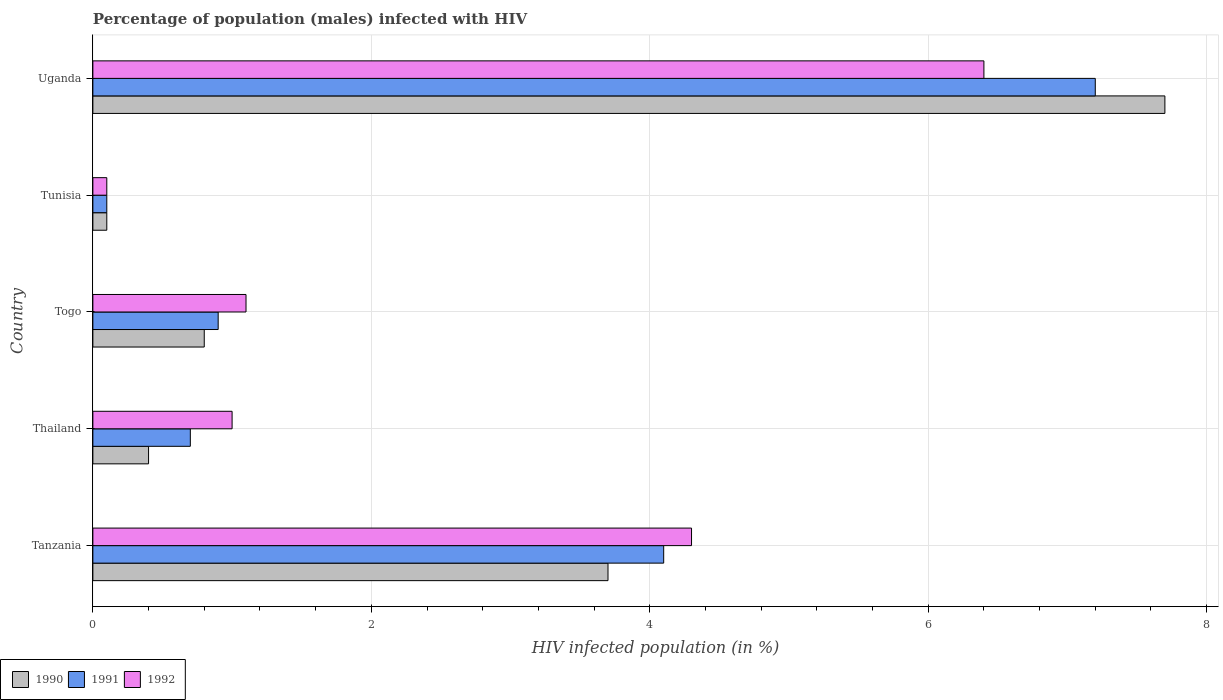Are the number of bars per tick equal to the number of legend labels?
Offer a terse response. Yes. How many bars are there on the 1st tick from the top?
Keep it short and to the point. 3. What is the label of the 1st group of bars from the top?
Keep it short and to the point. Uganda. In how many cases, is the number of bars for a given country not equal to the number of legend labels?
Ensure brevity in your answer.  0. What is the percentage of HIV infected male population in 1991 in Tanzania?
Your answer should be very brief. 4.1. Across all countries, what is the maximum percentage of HIV infected male population in 1990?
Your answer should be compact. 7.7. In which country was the percentage of HIV infected male population in 1991 maximum?
Give a very brief answer. Uganda. In which country was the percentage of HIV infected male population in 1991 minimum?
Make the answer very short. Tunisia. What is the difference between the percentage of HIV infected male population in 1990 in Tanzania and that in Togo?
Provide a succinct answer. 2.9. What is the average percentage of HIV infected male population in 1992 per country?
Your answer should be compact. 2.58. What is the difference between the percentage of HIV infected male population in 1992 and percentage of HIV infected male population in 1991 in Tanzania?
Ensure brevity in your answer.  0.2. What is the difference between the highest and the lowest percentage of HIV infected male population in 1991?
Offer a terse response. 7.1. In how many countries, is the percentage of HIV infected male population in 1990 greater than the average percentage of HIV infected male population in 1990 taken over all countries?
Provide a short and direct response. 2. Is the sum of the percentage of HIV infected male population in 1990 in Togo and Uganda greater than the maximum percentage of HIV infected male population in 1991 across all countries?
Give a very brief answer. Yes. What does the 3rd bar from the bottom in Togo represents?
Your answer should be very brief. 1992. Is it the case that in every country, the sum of the percentage of HIV infected male population in 1991 and percentage of HIV infected male population in 1992 is greater than the percentage of HIV infected male population in 1990?
Keep it short and to the point. Yes. How many bars are there?
Give a very brief answer. 15. Are all the bars in the graph horizontal?
Offer a terse response. Yes. How many countries are there in the graph?
Ensure brevity in your answer.  5. What is the difference between two consecutive major ticks on the X-axis?
Your response must be concise. 2. Does the graph contain any zero values?
Keep it short and to the point. No. Where does the legend appear in the graph?
Keep it short and to the point. Bottom left. How many legend labels are there?
Give a very brief answer. 3. How are the legend labels stacked?
Provide a succinct answer. Horizontal. What is the title of the graph?
Offer a very short reply. Percentage of population (males) infected with HIV. Does "1989" appear as one of the legend labels in the graph?
Offer a terse response. No. What is the label or title of the X-axis?
Ensure brevity in your answer.  HIV infected population (in %). What is the label or title of the Y-axis?
Your answer should be very brief. Country. What is the HIV infected population (in %) in 1991 in Tanzania?
Your answer should be compact. 4.1. What is the HIV infected population (in %) of 1991 in Thailand?
Provide a short and direct response. 0.7. What is the HIV infected population (in %) in 1992 in Thailand?
Give a very brief answer. 1. What is the HIV infected population (in %) in 1991 in Tunisia?
Offer a terse response. 0.1. What is the HIV infected population (in %) of 1990 in Uganda?
Keep it short and to the point. 7.7. What is the HIV infected population (in %) in 1991 in Uganda?
Offer a terse response. 7.2. What is the HIV infected population (in %) in 1992 in Uganda?
Offer a very short reply. 6.4. Across all countries, what is the maximum HIV infected population (in %) of 1990?
Your answer should be compact. 7.7. Across all countries, what is the maximum HIV infected population (in %) in 1992?
Offer a terse response. 6.4. Across all countries, what is the minimum HIV infected population (in %) of 1991?
Your answer should be compact. 0.1. Across all countries, what is the minimum HIV infected population (in %) of 1992?
Keep it short and to the point. 0.1. What is the total HIV infected population (in %) of 1990 in the graph?
Offer a terse response. 12.7. What is the difference between the HIV infected population (in %) in 1990 in Tanzania and that in Thailand?
Provide a short and direct response. 3.3. What is the difference between the HIV infected population (in %) in 1991 in Tanzania and that in Togo?
Offer a terse response. 3.2. What is the difference between the HIV infected population (in %) in 1992 in Tanzania and that in Togo?
Provide a short and direct response. 3.2. What is the difference between the HIV infected population (in %) of 1990 in Tanzania and that in Tunisia?
Make the answer very short. 3.6. What is the difference between the HIV infected population (in %) in 1992 in Tanzania and that in Tunisia?
Offer a very short reply. 4.2. What is the difference between the HIV infected population (in %) of 1991 in Tanzania and that in Uganda?
Your answer should be compact. -3.1. What is the difference between the HIV infected population (in %) of 1992 in Tanzania and that in Uganda?
Your answer should be compact. -2.1. What is the difference between the HIV infected population (in %) of 1990 in Thailand and that in Tunisia?
Offer a very short reply. 0.3. What is the difference between the HIV infected population (in %) in 1992 in Thailand and that in Tunisia?
Keep it short and to the point. 0.9. What is the difference between the HIV infected population (in %) in 1990 in Thailand and that in Uganda?
Provide a short and direct response. -7.3. What is the difference between the HIV infected population (in %) in 1991 in Thailand and that in Uganda?
Provide a short and direct response. -6.5. What is the difference between the HIV infected population (in %) in 1992 in Thailand and that in Uganda?
Your answer should be very brief. -5.4. What is the difference between the HIV infected population (in %) in 1992 in Togo and that in Tunisia?
Provide a short and direct response. 1. What is the difference between the HIV infected population (in %) in 1992 in Togo and that in Uganda?
Offer a very short reply. -5.3. What is the difference between the HIV infected population (in %) of 1990 in Tunisia and that in Uganda?
Offer a terse response. -7.6. What is the difference between the HIV infected population (in %) in 1992 in Tunisia and that in Uganda?
Your response must be concise. -6.3. What is the difference between the HIV infected population (in %) of 1990 in Tanzania and the HIV infected population (in %) of 1992 in Thailand?
Offer a very short reply. 2.7. What is the difference between the HIV infected population (in %) of 1990 in Tanzania and the HIV infected population (in %) of 1992 in Togo?
Make the answer very short. 2.6. What is the difference between the HIV infected population (in %) in 1991 in Tanzania and the HIV infected population (in %) in 1992 in Togo?
Give a very brief answer. 3. What is the difference between the HIV infected population (in %) in 1990 in Tanzania and the HIV infected population (in %) in 1992 in Uganda?
Offer a terse response. -2.7. What is the difference between the HIV infected population (in %) of 1990 in Thailand and the HIV infected population (in %) of 1992 in Uganda?
Your answer should be very brief. -6. What is the difference between the HIV infected population (in %) in 1991 in Thailand and the HIV infected population (in %) in 1992 in Uganda?
Offer a very short reply. -5.7. What is the difference between the HIV infected population (in %) in 1990 in Togo and the HIV infected population (in %) in 1991 in Tunisia?
Your response must be concise. 0.7. What is the difference between the HIV infected population (in %) of 1990 in Togo and the HIV infected population (in %) of 1992 in Tunisia?
Offer a terse response. 0.7. What is the difference between the HIV infected population (in %) of 1990 in Togo and the HIV infected population (in %) of 1991 in Uganda?
Give a very brief answer. -6.4. What is the difference between the HIV infected population (in %) of 1991 in Togo and the HIV infected population (in %) of 1992 in Uganda?
Offer a very short reply. -5.5. What is the difference between the HIV infected population (in %) in 1990 in Tunisia and the HIV infected population (in %) in 1992 in Uganda?
Offer a terse response. -6.3. What is the difference between the HIV infected population (in %) of 1991 in Tunisia and the HIV infected population (in %) of 1992 in Uganda?
Offer a terse response. -6.3. What is the average HIV infected population (in %) of 1990 per country?
Offer a very short reply. 2.54. What is the average HIV infected population (in %) in 1991 per country?
Your answer should be very brief. 2.6. What is the average HIV infected population (in %) of 1992 per country?
Ensure brevity in your answer.  2.58. What is the difference between the HIV infected population (in %) of 1990 and HIV infected population (in %) of 1991 in Tanzania?
Provide a short and direct response. -0.4. What is the difference between the HIV infected population (in %) of 1990 and HIV infected population (in %) of 1992 in Tanzania?
Give a very brief answer. -0.6. What is the difference between the HIV infected population (in %) of 1990 and HIV infected population (in %) of 1992 in Thailand?
Your answer should be compact. -0.6. What is the difference between the HIV infected population (in %) in 1991 and HIV infected population (in %) in 1992 in Thailand?
Make the answer very short. -0.3. What is the difference between the HIV infected population (in %) of 1990 and HIV infected population (in %) of 1991 in Togo?
Your answer should be very brief. -0.1. What is the difference between the HIV infected population (in %) of 1990 and HIV infected population (in %) of 1992 in Togo?
Make the answer very short. -0.3. What is the difference between the HIV infected population (in %) of 1990 and HIV infected population (in %) of 1991 in Tunisia?
Your response must be concise. 0. What is the difference between the HIV infected population (in %) of 1990 and HIV infected population (in %) of 1991 in Uganda?
Keep it short and to the point. 0.5. What is the difference between the HIV infected population (in %) of 1991 and HIV infected population (in %) of 1992 in Uganda?
Provide a short and direct response. 0.8. What is the ratio of the HIV infected population (in %) in 1990 in Tanzania to that in Thailand?
Make the answer very short. 9.25. What is the ratio of the HIV infected population (in %) in 1991 in Tanzania to that in Thailand?
Your answer should be compact. 5.86. What is the ratio of the HIV infected population (in %) in 1992 in Tanzania to that in Thailand?
Your response must be concise. 4.3. What is the ratio of the HIV infected population (in %) in 1990 in Tanzania to that in Togo?
Provide a succinct answer. 4.62. What is the ratio of the HIV infected population (in %) in 1991 in Tanzania to that in Togo?
Offer a very short reply. 4.56. What is the ratio of the HIV infected population (in %) in 1992 in Tanzania to that in Togo?
Provide a succinct answer. 3.91. What is the ratio of the HIV infected population (in %) in 1991 in Tanzania to that in Tunisia?
Your response must be concise. 41. What is the ratio of the HIV infected population (in %) in 1992 in Tanzania to that in Tunisia?
Offer a very short reply. 43. What is the ratio of the HIV infected population (in %) in 1990 in Tanzania to that in Uganda?
Offer a very short reply. 0.48. What is the ratio of the HIV infected population (in %) in 1991 in Tanzania to that in Uganda?
Your response must be concise. 0.57. What is the ratio of the HIV infected population (in %) in 1992 in Tanzania to that in Uganda?
Provide a succinct answer. 0.67. What is the ratio of the HIV infected population (in %) of 1991 in Thailand to that in Tunisia?
Your answer should be compact. 7. What is the ratio of the HIV infected population (in %) of 1990 in Thailand to that in Uganda?
Keep it short and to the point. 0.05. What is the ratio of the HIV infected population (in %) in 1991 in Thailand to that in Uganda?
Your answer should be very brief. 0.1. What is the ratio of the HIV infected population (in %) in 1992 in Thailand to that in Uganda?
Your answer should be very brief. 0.16. What is the ratio of the HIV infected population (in %) of 1992 in Togo to that in Tunisia?
Your answer should be very brief. 11. What is the ratio of the HIV infected population (in %) in 1990 in Togo to that in Uganda?
Your answer should be compact. 0.1. What is the ratio of the HIV infected population (in %) of 1991 in Togo to that in Uganda?
Keep it short and to the point. 0.12. What is the ratio of the HIV infected population (in %) in 1992 in Togo to that in Uganda?
Make the answer very short. 0.17. What is the ratio of the HIV infected population (in %) of 1990 in Tunisia to that in Uganda?
Give a very brief answer. 0.01. What is the ratio of the HIV infected population (in %) of 1991 in Tunisia to that in Uganda?
Give a very brief answer. 0.01. What is the ratio of the HIV infected population (in %) in 1992 in Tunisia to that in Uganda?
Keep it short and to the point. 0.02. What is the difference between the highest and the lowest HIV infected population (in %) of 1991?
Ensure brevity in your answer.  7.1. What is the difference between the highest and the lowest HIV infected population (in %) of 1992?
Make the answer very short. 6.3. 